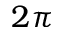Convert formula to latex. <formula><loc_0><loc_0><loc_500><loc_500>2 \pi</formula> 